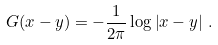<formula> <loc_0><loc_0><loc_500><loc_500>G ( x - y ) = - \frac { 1 } { 2 \pi } \log \left | x - y \right | \, .</formula> 